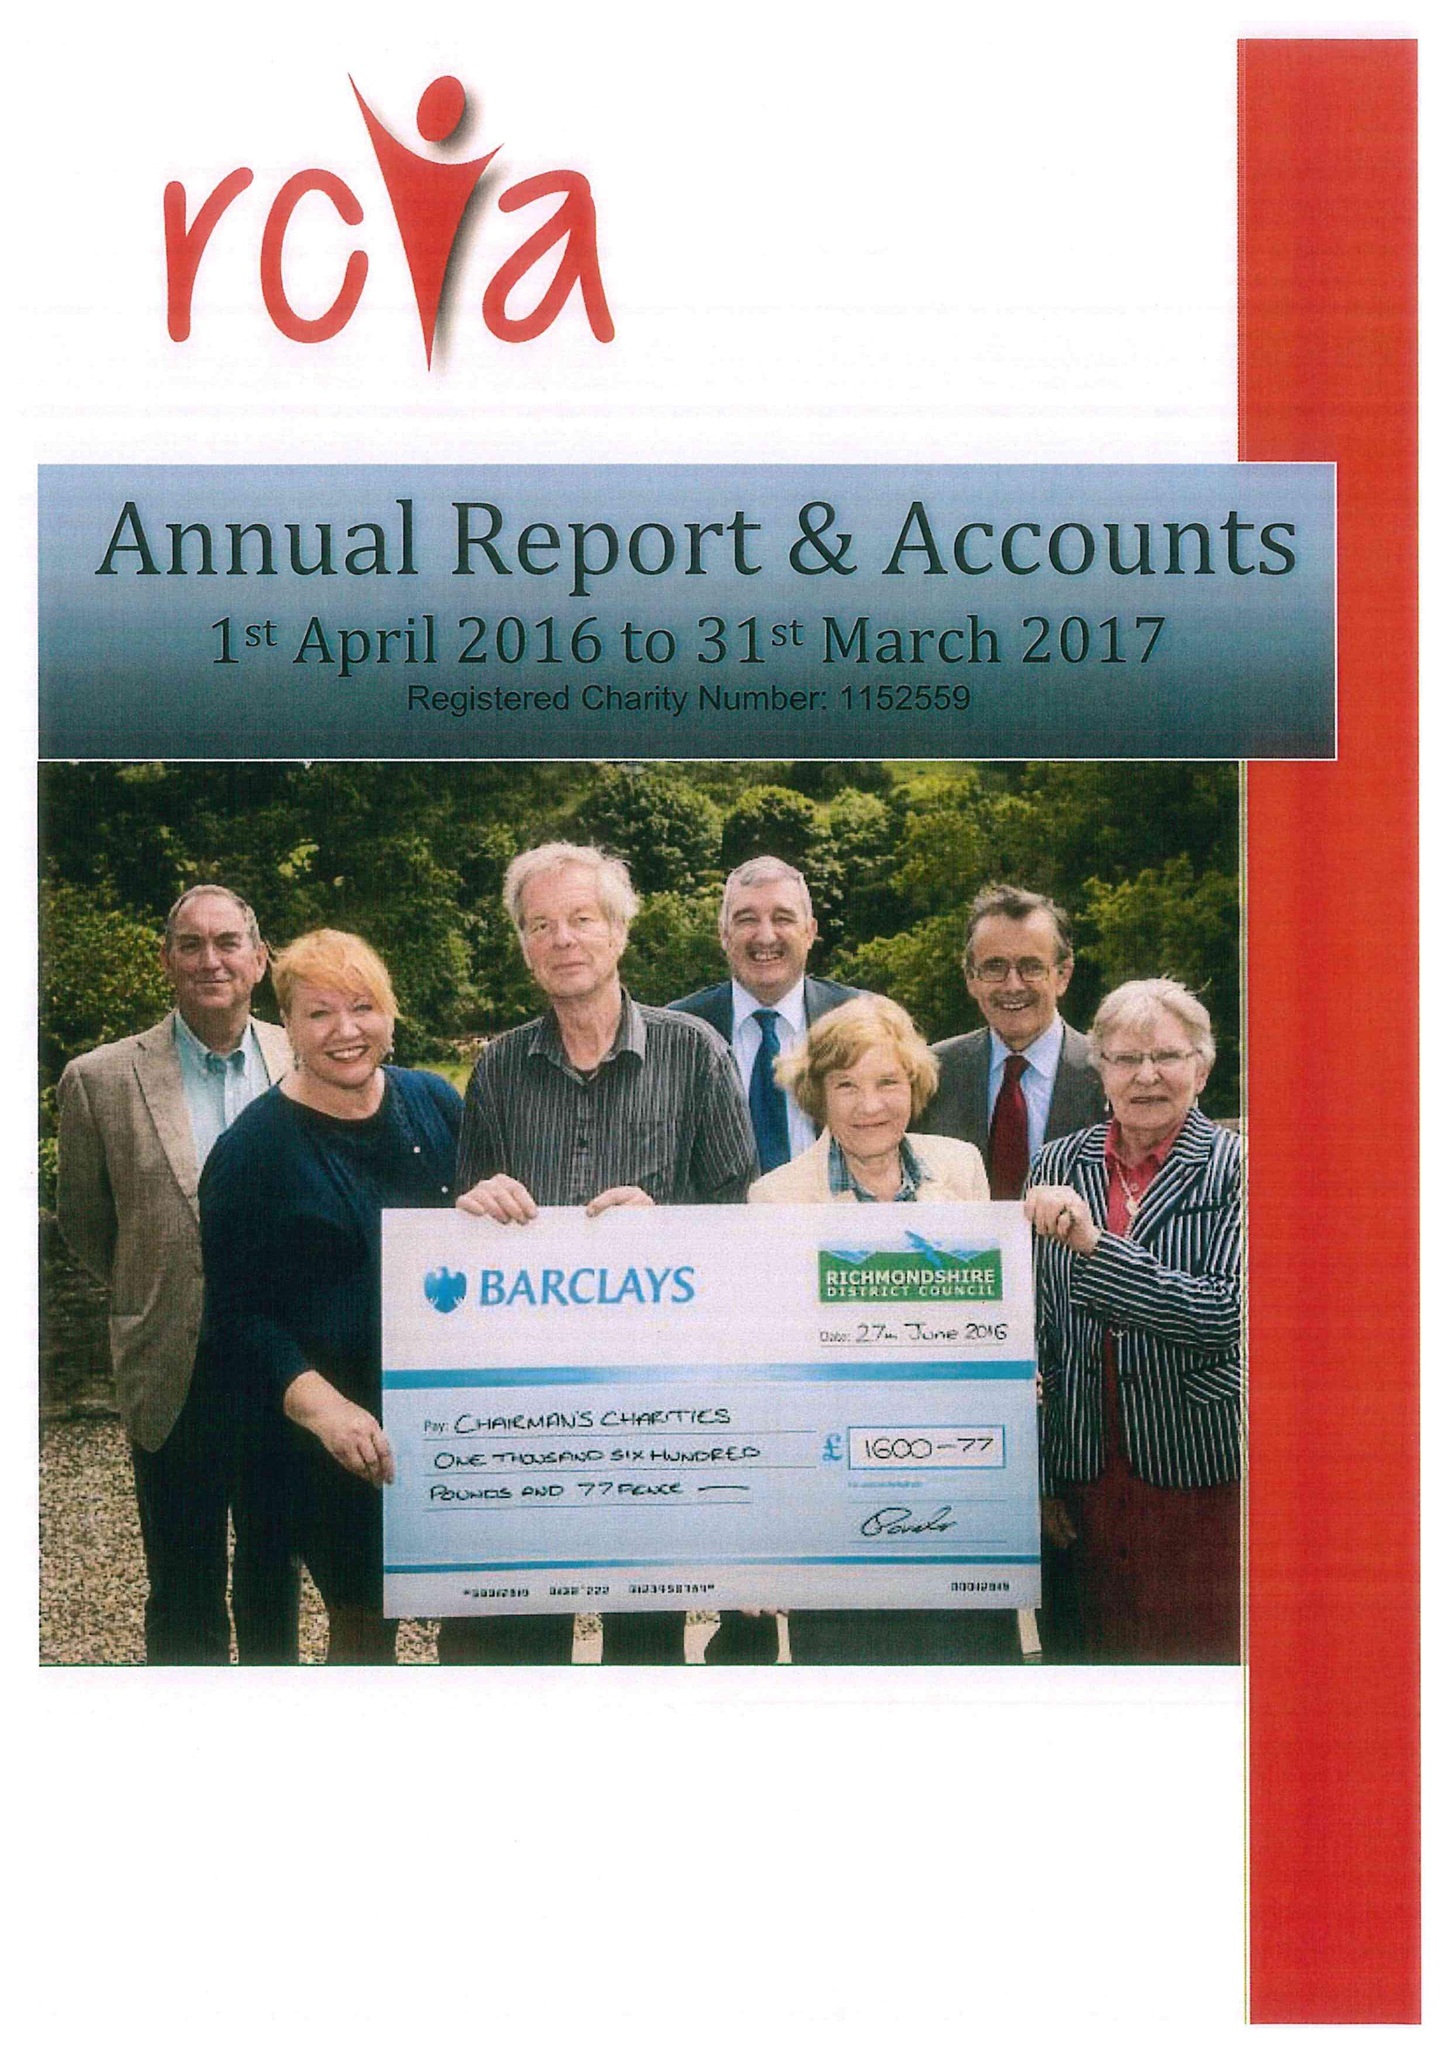What is the value for the address__post_town?
Answer the question using a single word or phrase. CATTERICK GARRISON 